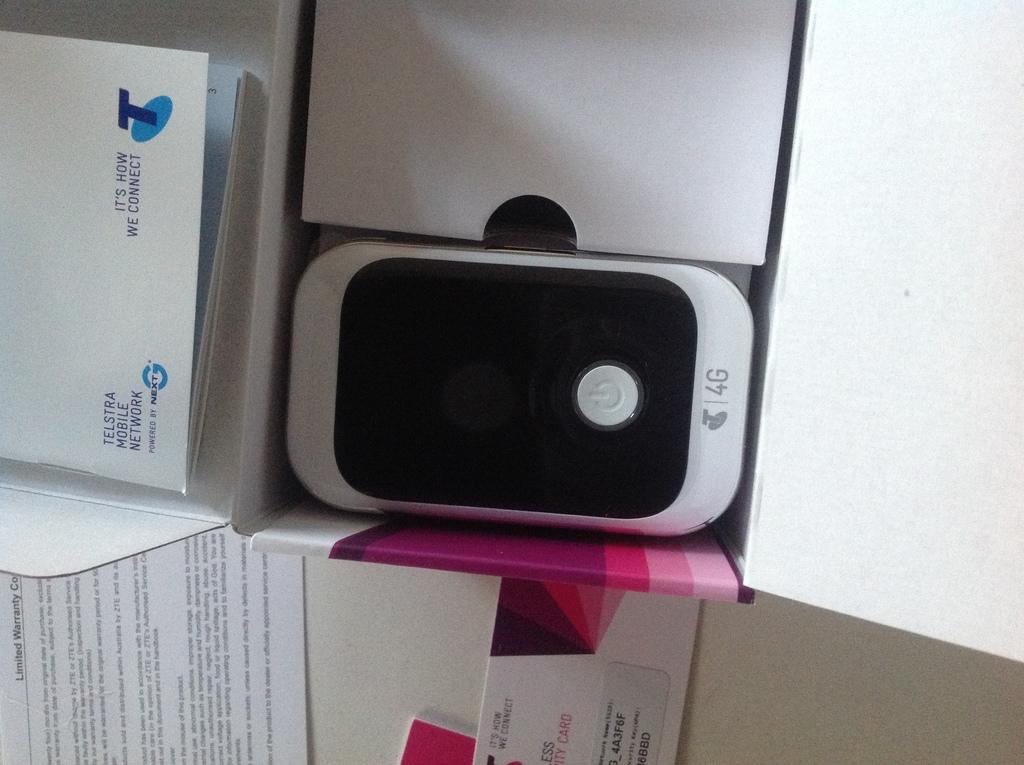<image>
Present a compact description of the photo's key features. A small cell phone sitting next to a box that says It's How We Connect on it. 